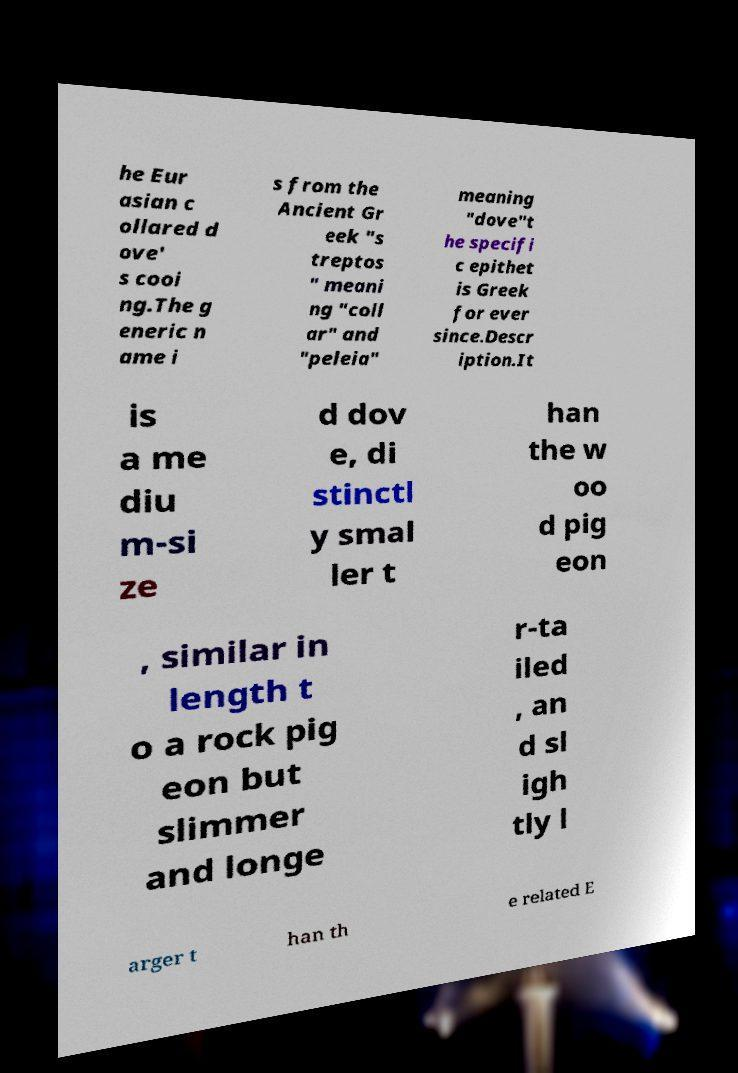Could you assist in decoding the text presented in this image and type it out clearly? he Eur asian c ollared d ove' s cooi ng.The g eneric n ame i s from the Ancient Gr eek "s treptos " meani ng "coll ar" and "peleia" meaning "dove"t he specifi c epithet is Greek for ever since.Descr iption.It is a me diu m-si ze d dov e, di stinctl y smal ler t han the w oo d pig eon , similar in length t o a rock pig eon but slimmer and longe r-ta iled , an d sl igh tly l arger t han th e related E 